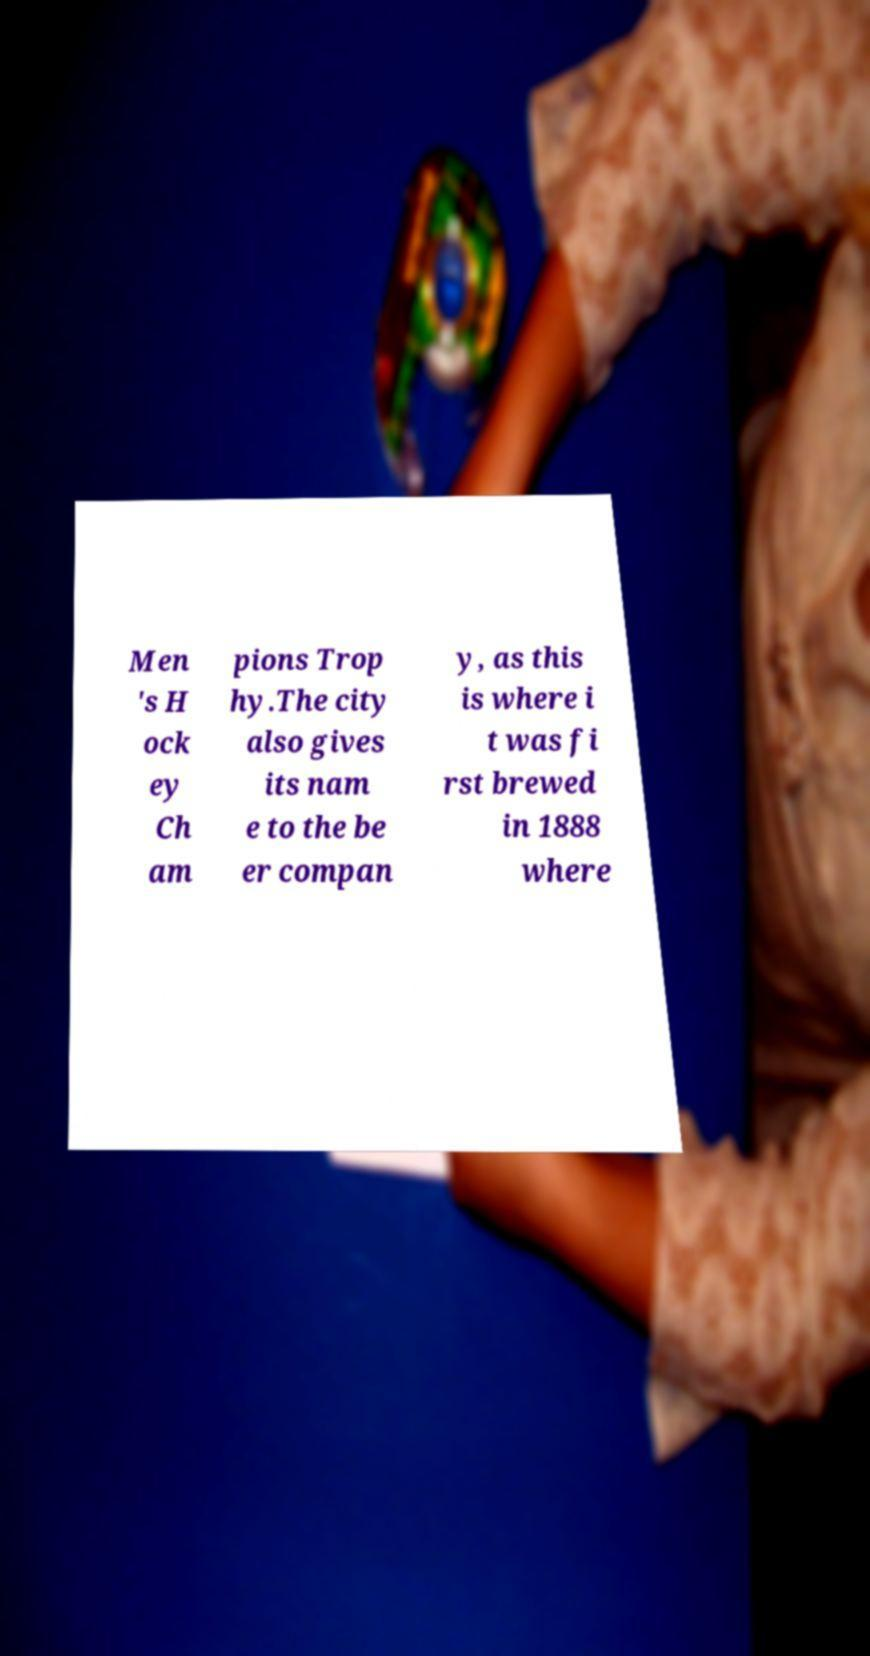Could you assist in decoding the text presented in this image and type it out clearly? Men 's H ock ey Ch am pions Trop hy.The city also gives its nam e to the be er compan y, as this is where i t was fi rst brewed in 1888 where 